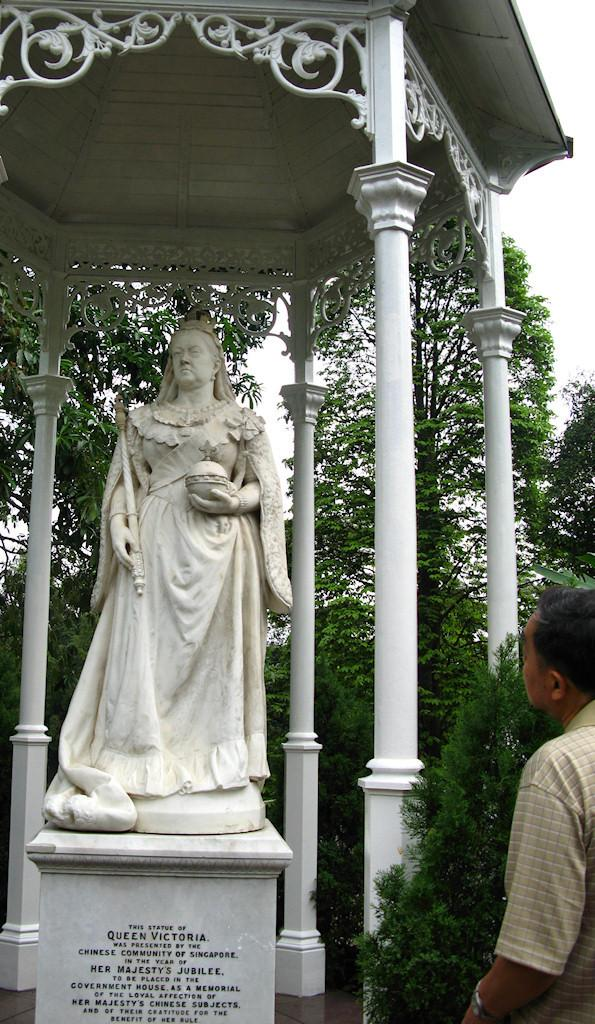What is the main subject in the image? There is a statue in the image. What architectural features can be seen in the image? There are pillars in the image. What type of natural elements are present in the image? There are trees in the image. Can you describe the person in the image? There is a person standing on the right side of the image. How does the person say good-bye to the statue in the image? There is no indication in the image that the person is saying good-bye to the statue, nor is there any interaction between them. 